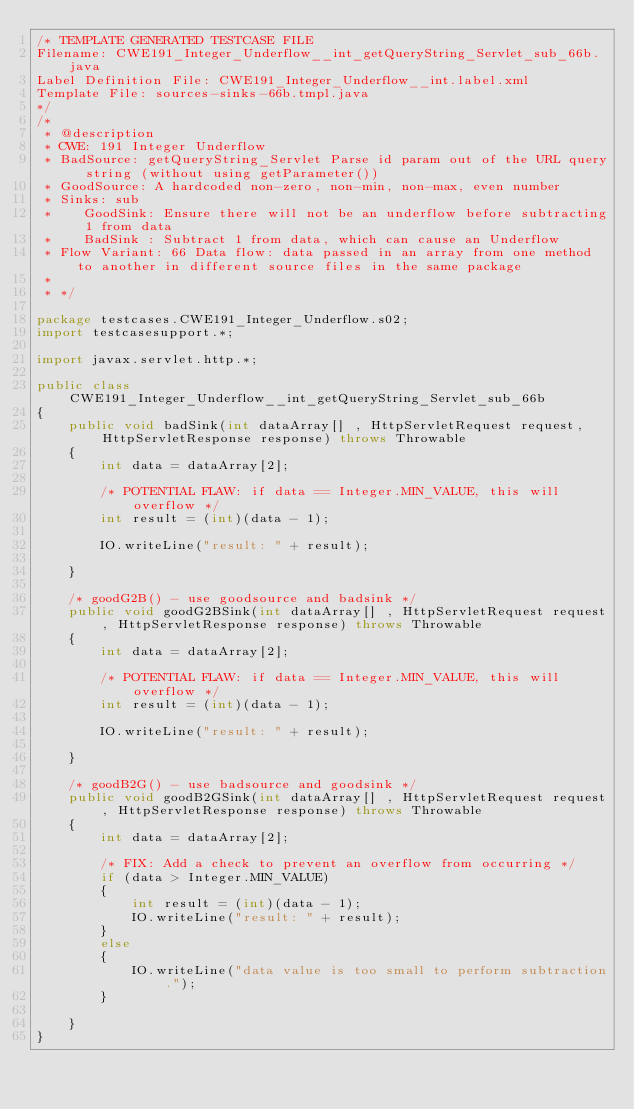Convert code to text. <code><loc_0><loc_0><loc_500><loc_500><_Java_>/* TEMPLATE GENERATED TESTCASE FILE
Filename: CWE191_Integer_Underflow__int_getQueryString_Servlet_sub_66b.java
Label Definition File: CWE191_Integer_Underflow__int.label.xml
Template File: sources-sinks-66b.tmpl.java
*/
/*
 * @description
 * CWE: 191 Integer Underflow
 * BadSource: getQueryString_Servlet Parse id param out of the URL query string (without using getParameter())
 * GoodSource: A hardcoded non-zero, non-min, non-max, even number
 * Sinks: sub
 *    GoodSink: Ensure there will not be an underflow before subtracting 1 from data
 *    BadSink : Subtract 1 from data, which can cause an Underflow
 * Flow Variant: 66 Data flow: data passed in an array from one method to another in different source files in the same package
 *
 * */

package testcases.CWE191_Integer_Underflow.s02;
import testcasesupport.*;

import javax.servlet.http.*;

public class CWE191_Integer_Underflow__int_getQueryString_Servlet_sub_66b
{
    public void badSink(int dataArray[] , HttpServletRequest request, HttpServletResponse response) throws Throwable
    {
        int data = dataArray[2];

        /* POTENTIAL FLAW: if data == Integer.MIN_VALUE, this will overflow */
        int result = (int)(data - 1);

        IO.writeLine("result: " + result);

    }

    /* goodG2B() - use goodsource and badsink */
    public void goodG2BSink(int dataArray[] , HttpServletRequest request, HttpServletResponse response) throws Throwable
    {
        int data = dataArray[2];

        /* POTENTIAL FLAW: if data == Integer.MIN_VALUE, this will overflow */
        int result = (int)(data - 1);

        IO.writeLine("result: " + result);

    }

    /* goodB2G() - use badsource and goodsink */
    public void goodB2GSink(int dataArray[] , HttpServletRequest request, HttpServletResponse response) throws Throwable
    {
        int data = dataArray[2];

        /* FIX: Add a check to prevent an overflow from occurring */
        if (data > Integer.MIN_VALUE)
        {
            int result = (int)(data - 1);
            IO.writeLine("result: " + result);
        }
        else
        {
            IO.writeLine("data value is too small to perform subtraction.");
        }

    }
}
</code> 